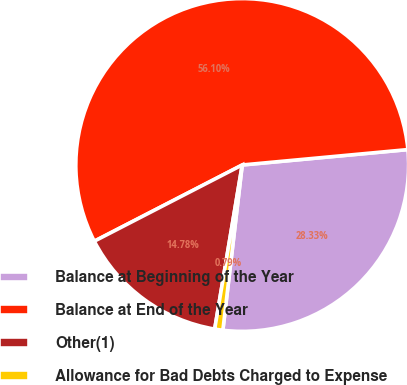Convert chart to OTSL. <chart><loc_0><loc_0><loc_500><loc_500><pie_chart><fcel>Balance at Beginning of the Year<fcel>Balance at End of the Year<fcel>Other(1)<fcel>Allowance for Bad Debts Charged to Expense<nl><fcel>28.33%<fcel>56.1%<fcel>14.78%<fcel>0.79%<nl></chart> 